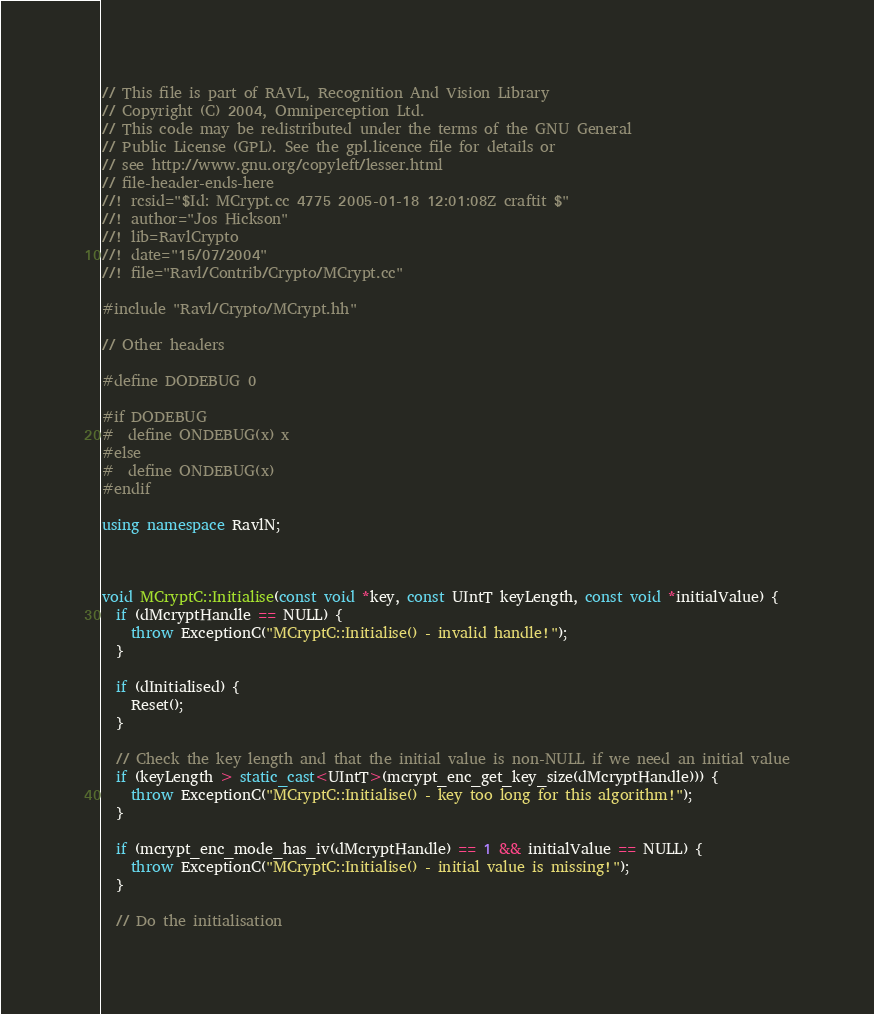<code> <loc_0><loc_0><loc_500><loc_500><_C++_>// This file is part of RAVL, Recognition And Vision Library 
// Copyright (C) 2004, Omniperception Ltd.
// This code may be redistributed under the terms of the GNU General 
// Public License (GPL). See the gpl.licence file for details or
// see http://www.gnu.org/copyleft/lesser.html
// file-header-ends-here
//! rcsid="$Id: MCrypt.cc 4775 2005-01-18 12:01:08Z craftit $"
//! author="Jos Hickson"
//! lib=RavlCrypto
//! date="15/07/2004"
//! file="Ravl/Contrib/Crypto/MCrypt.cc"

#include "Ravl/Crypto/MCrypt.hh"

// Other headers

#define DODEBUG 0

#if DODEBUG
#  define ONDEBUG(x) x
#else
#  define ONDEBUG(x)
#endif

using namespace RavlN;



void MCryptC::Initialise(const void *key, const UIntT keyLength, const void *initialValue) {
  if (dMcryptHandle == NULL) {
    throw ExceptionC("MCryptC::Initialise() - invalid handle!");
  }

  if (dInitialised) {
    Reset();
  }

  // Check the key length and that the initial value is non-NULL if we need an initial value
  if (keyLength > static_cast<UIntT>(mcrypt_enc_get_key_size(dMcryptHandle))) {
    throw ExceptionC("MCryptC::Initialise() - key too long for this algorithm!");
  }

  if (mcrypt_enc_mode_has_iv(dMcryptHandle) == 1 && initialValue == NULL) {
    throw ExceptionC("MCryptC::Initialise() - initial value is missing!");
  }

  // Do the initialisation</code> 